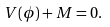<formula> <loc_0><loc_0><loc_500><loc_500>V ( \phi ) + M = 0 .</formula> 